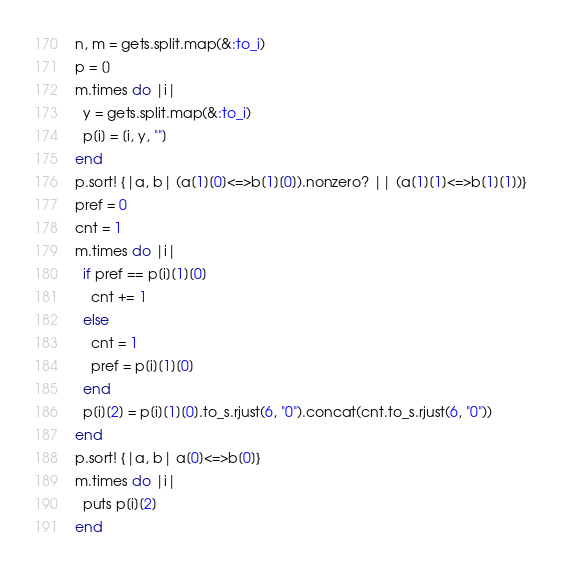<code> <loc_0><loc_0><loc_500><loc_500><_Ruby_>n, m = gets.split.map(&:to_i)
p = []
m.times do |i|
  y = gets.split.map(&:to_i)
  p[i] = [i, y, ""]
end
p.sort! {|a, b| (a[1][0]<=>b[1][0]).nonzero? || (a[1][1]<=>b[1][1])}
pref = 0
cnt = 1
m.times do |i|
  if pref == p[i][1][0]
    cnt += 1
  else
    cnt = 1
    pref = p[i][1][0]
  end
  p[i][2] = p[i][1][0].to_s.rjust(6, "0").concat(cnt.to_s.rjust(6, "0"))
end
p.sort! {|a, b| a[0]<=>b[0]}
m.times do |i|
  puts p[i][2]
end</code> 